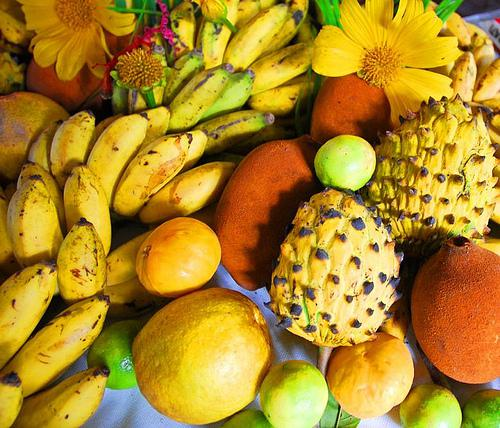Question: what is the yellow long fruit?
Choices:
A. Peppers.
B. Mango.
C. Bananas.
D. Sliced peaches.
Answer with the letter. Answer: C Question: how many different fruits are there?
Choices:
A. Six.
B. Five.
C. Four.
D. Seven.
Answer with the letter. Answer: A Question: what is the orange fruit?
Choices:
A. Oranges.
B. Grapefruit.
C. Limes.
D. Lemons.
Answer with the letter. Answer: A Question: what color are the limes?
Choices:
A. Yellow.
B. Brown.
C. Red.
D. Green.
Answer with the letter. Answer: D Question: what color are the flowers?
Choices:
A. Pink.
B. Blue.
C. Red.
D. Yellow.
Answer with the letter. Answer: D Question: who is eating the fruit?
Choices:
A. MaeMae.
B. No one.
C. The man.
D. The dog.
Answer with the letter. Answer: B Question: where are the fruits?
Choices:
A. Tablecloth.
B. Bowl.
C. On tree.
D. On a plate.
Answer with the letter. Answer: A 